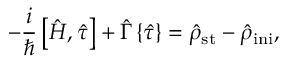Convert formula to latex. <formula><loc_0><loc_0><loc_500><loc_500>- \frac { i } { } \left [ { \hat { H } } , { \hat { \tau } } \right ] + { \hat { \Gamma } } \left \{ { \hat { \tau } } \right \} = { \hat { \rho } } _ { s t } - { \hat { \rho } } _ { i n i } ,</formula> 